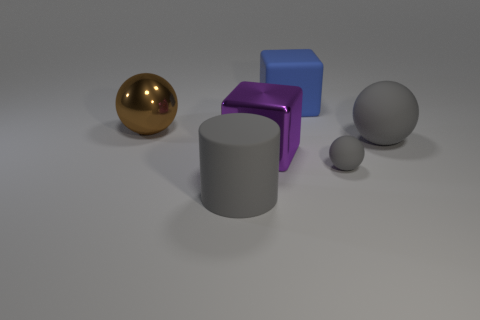Subtract all matte balls. How many balls are left? 1 Subtract all yellow cylinders. How many gray spheres are left? 2 Add 1 metal things. How many objects exist? 7 Subtract 1 spheres. How many spheres are left? 2 Subtract all cylinders. How many objects are left? 5 Subtract all yellow balls. Subtract all green cylinders. How many balls are left? 3 Add 2 large rubber spheres. How many large rubber spheres are left? 3 Add 3 large brown balls. How many large brown balls exist? 4 Subtract 0 green blocks. How many objects are left? 6 Subtract all big brown metal balls. Subtract all blocks. How many objects are left? 3 